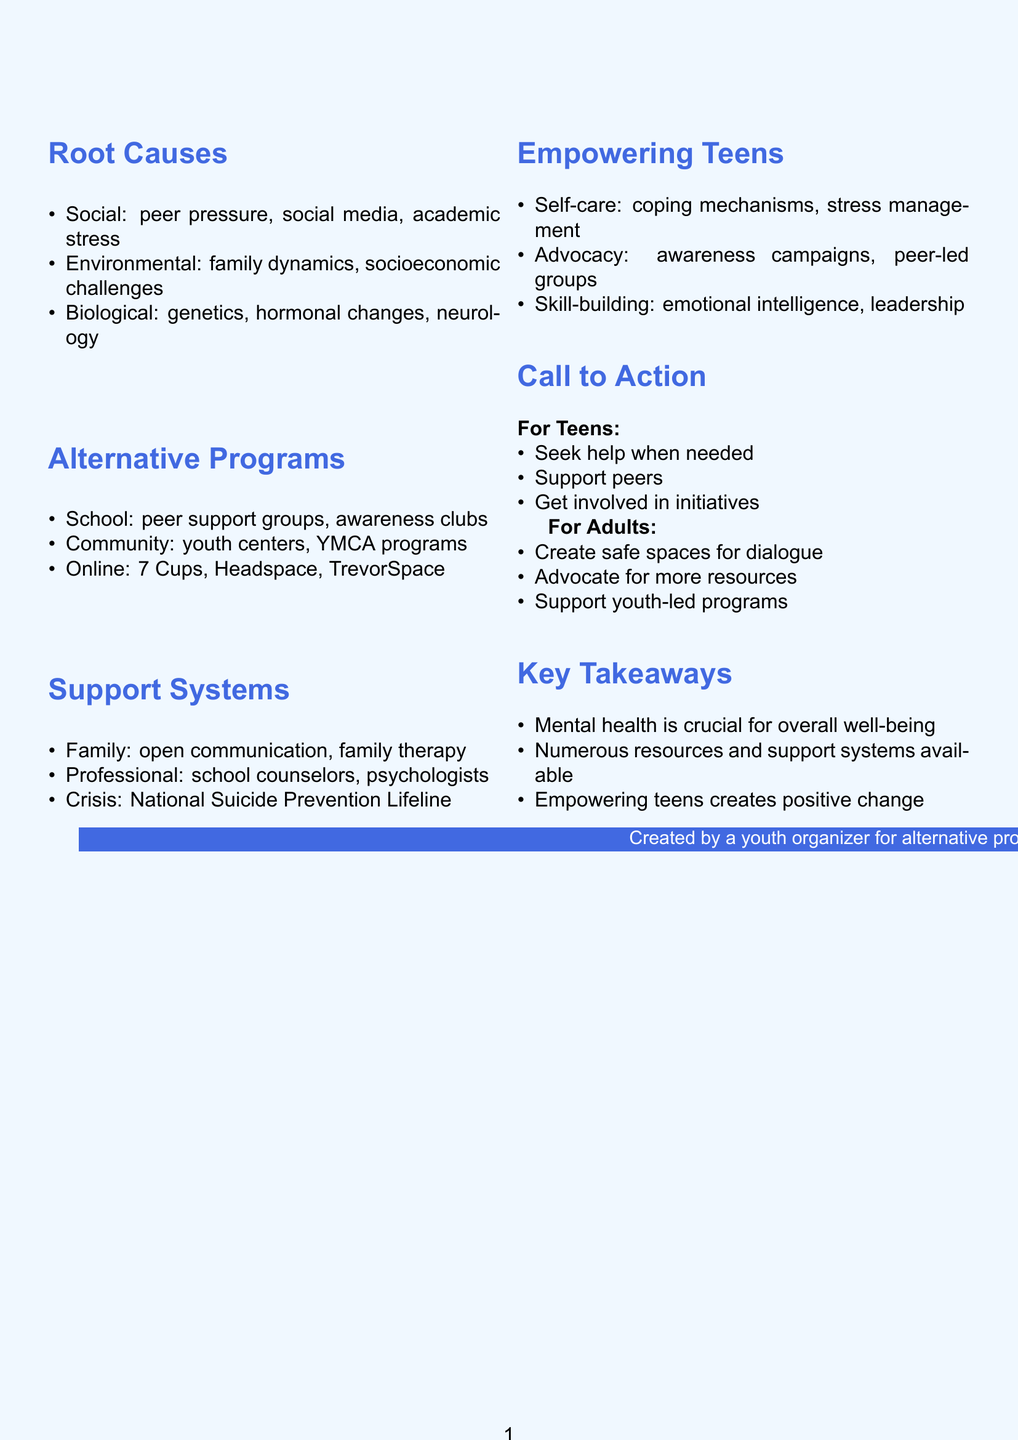what is the title of the presentation? The title of the presentation is stated at the beginning of the document.
Answer: Empowering Teens: Mental Health Resources and Support Systems how many social factors contribute to mental health issues? The document lists three social factors contributing to mental health issues.
Answer: 3 what are two examples of community resources mentioned? Two examples of community resources can be found under the alternative programs section.
Answer: Youth centers: The Boys & Girls Clubs of America, Local YMCA mental health programs what is one self-care technique suggested for teens? One self-care technique is highlighted in the empowering teens section of the document.
Answer: Developing healthy coping mechanisms what should adults do to support mental health resources? The call to action section outlines suggestions for adults to support mental health resources.
Answer: Advocate for more mental health resources in schools and communities which type of support system includes school counselors? The support systems section of the document clarifies the different types of support available.
Answer: Professional help 